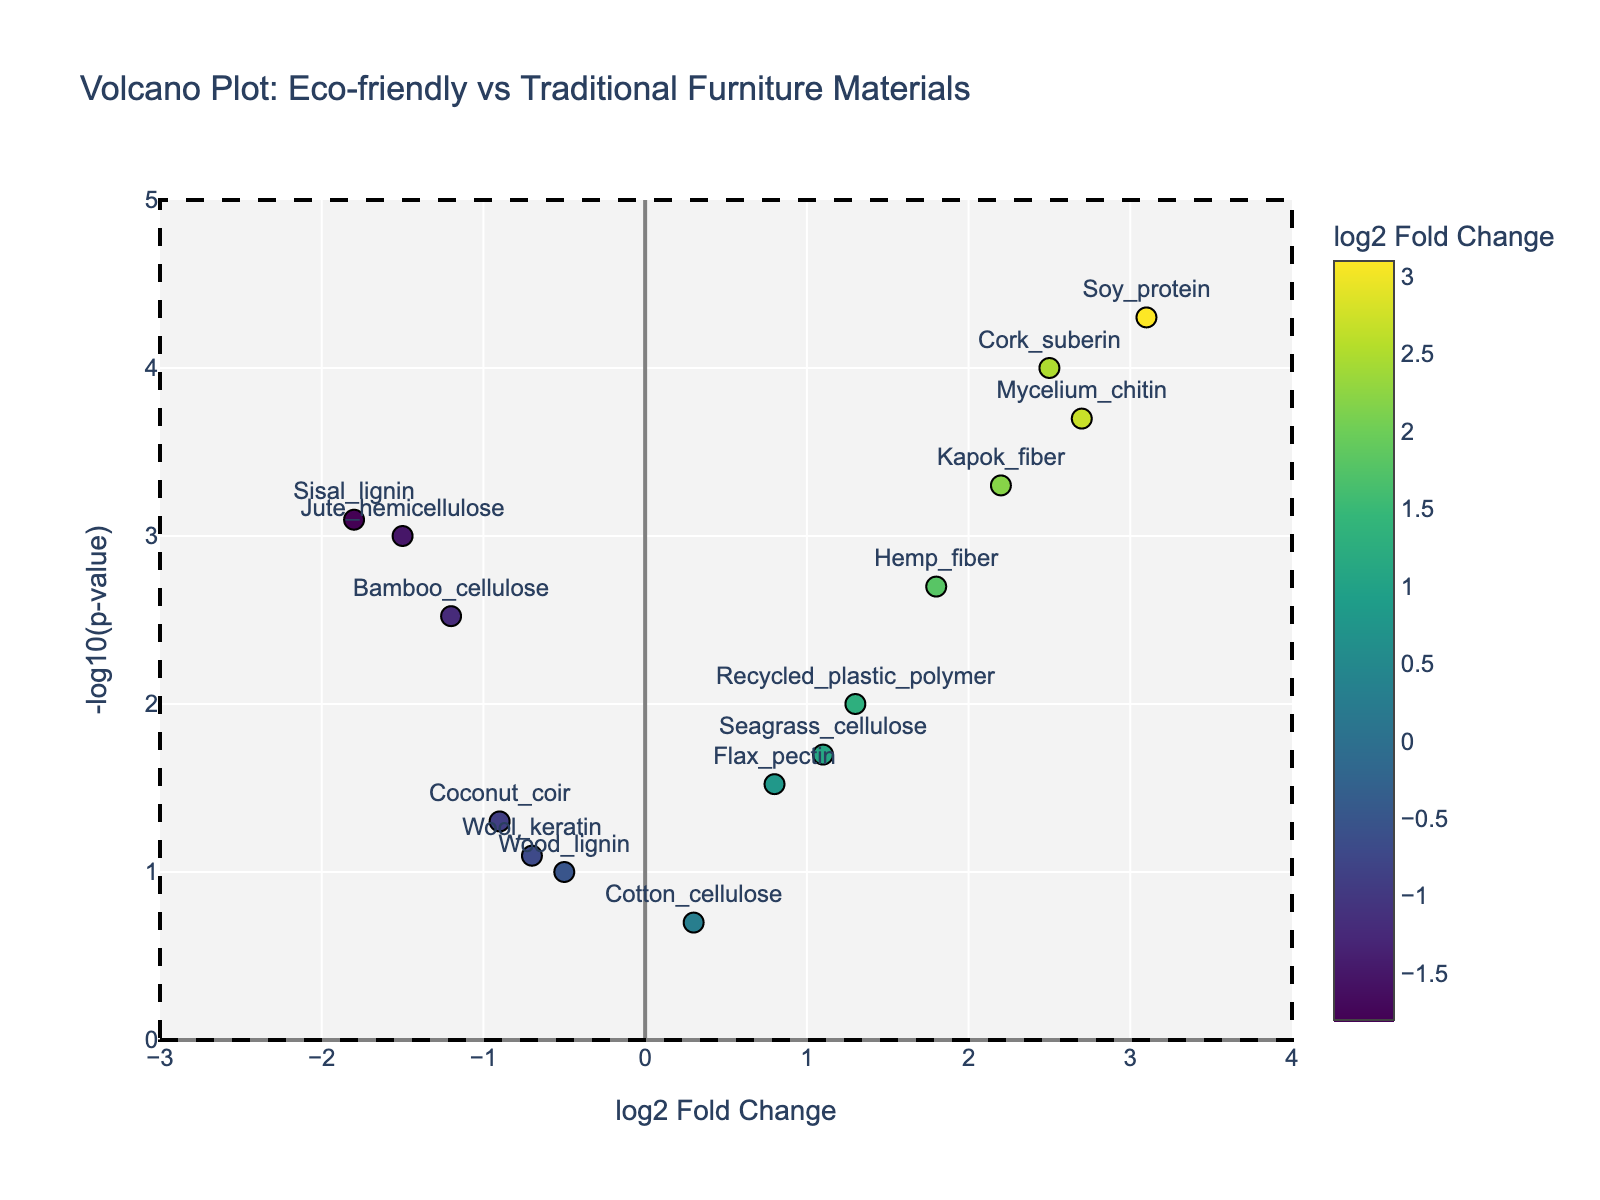Which protein has the highest log2 fold change? By looking at the plot, identify the data point positioned farthest to the right on the x-axis, which represents the log2 fold change. This data point is labeled with the protein's name.
Answer: Soy_protein What color does the p-value threshold line have? The p-value threshold line is a horizontal line, typically used to indicate a significant p-value cut-off. Check the color of the horizontal line in the plot.
Answer: Red How many proteins have a positive log2 fold change greater than 2? Search for data points to the right of the vertical line at log2 fold change of 2 on the plot. Count these data points.
Answer: Four Which protein is more significant than the threshold and has the most negative log2 fold change? Find the data points below the red horizontal line (significant p-value threshold). Among them, locate the one farthest to the left, indicating the most negative log2 fold change.
Answer: Sisal_lignin What are the log2 fold changes for Bamboo_cellulose and Cork_suberin, and which one is greater? Locate the points labeled Bamboo_cellulose and Cork_suberin on the plot and read their x-axis values. Compare these values to determine which log2 fold change is higher. Bamboo_cellulose is -1.2 and Cork_suberin is 2.5.
Answer: Cork_suberin How many proteins show a significant change (p-value < 0.05)? Identify the data points that fall below the red horizontal line, indicating a p-value less than 0.05. Count these points.
Answer: Ten Which two proteins have nearly identical -log10(p-values) but different log2 fold changes? Look for pairs of data points that align closely on the y-axis (-log10(p-value)) but diverge along the x-axis (log2 fold change).
Answer: Hemp_fiber and Bamboo_cellulose Which protein has the smallest -log10(p-value) among those with a negative log2 fold change? Look at the points on the left side of the x-axis (negative log2 fold change) and find the one that is lowest on the y-axis (-log10(p-value)).
Answer: Wood_lignin Which protein has the largest -log10(p-value), and what is its log2 fold change? Locate the point highest on the y-axis, which indicates the largest -log10(p-value). Read its log2 fold change value from the x-axis.
Answer: Soy_protein, 3.1 What is the range of log2 fold changes displayed in the plot? Check the x-axis for the minimum and maximum log2 fold change values. They span from about -3 to 4.
Answer: Approximately -3 to 4 